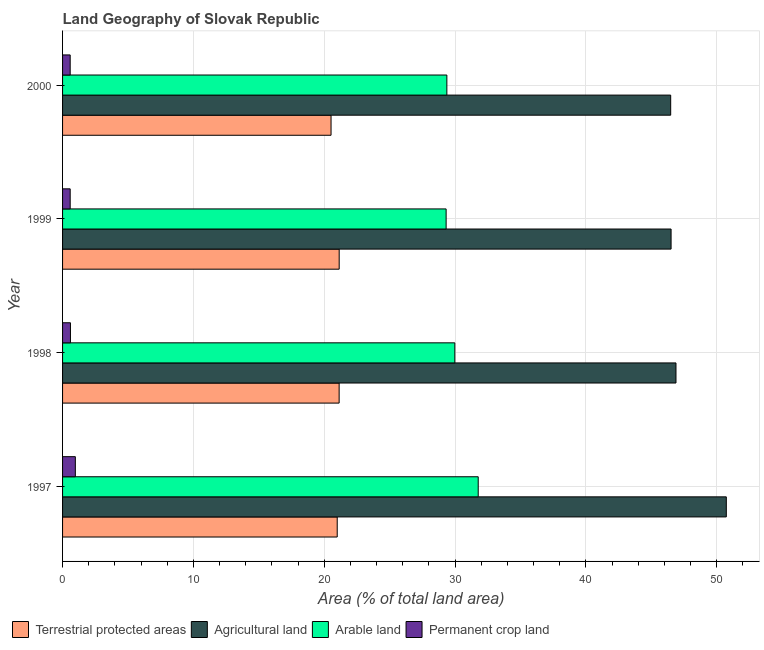How many different coloured bars are there?
Your answer should be very brief. 4. How many groups of bars are there?
Your response must be concise. 4. Are the number of bars per tick equal to the number of legend labels?
Give a very brief answer. Yes. How many bars are there on the 2nd tick from the top?
Keep it short and to the point. 4. How many bars are there on the 3rd tick from the bottom?
Make the answer very short. 4. In how many cases, is the number of bars for a given year not equal to the number of legend labels?
Keep it short and to the point. 0. What is the percentage of area under permanent crop land in 1999?
Give a very brief answer. 0.58. Across all years, what is the maximum percentage of area under permanent crop land?
Your answer should be very brief. 0.98. Across all years, what is the minimum percentage of area under permanent crop land?
Your answer should be compact. 0.58. In which year was the percentage of area under agricultural land maximum?
Provide a succinct answer. 1997. In which year was the percentage of area under permanent crop land minimum?
Offer a very short reply. 2000. What is the total percentage of area under arable land in the graph?
Make the answer very short. 120.43. What is the difference between the percentage of area under permanent crop land in 1998 and that in 2000?
Your answer should be very brief. 0.02. What is the difference between the percentage of area under arable land in 1997 and the percentage of area under agricultural land in 1998?
Make the answer very short. -15.11. What is the average percentage of area under permanent crop land per year?
Your answer should be compact. 0.69. In the year 1999, what is the difference between the percentage of area under permanent crop land and percentage of area under arable land?
Give a very brief answer. -28.73. Is the difference between the percentage of land under terrestrial protection in 1998 and 1999 greater than the difference between the percentage of area under permanent crop land in 1998 and 1999?
Make the answer very short. No. What is the difference between the highest and the second highest percentage of area under agricultural land?
Your answer should be compact. 3.85. In how many years, is the percentage of area under permanent crop land greater than the average percentage of area under permanent crop land taken over all years?
Your answer should be very brief. 1. Is it the case that in every year, the sum of the percentage of area under agricultural land and percentage of land under terrestrial protection is greater than the sum of percentage of area under arable land and percentage of area under permanent crop land?
Offer a very short reply. Yes. What does the 3rd bar from the top in 1999 represents?
Ensure brevity in your answer.  Agricultural land. What does the 3rd bar from the bottom in 1998 represents?
Your answer should be very brief. Arable land. Is it the case that in every year, the sum of the percentage of land under terrestrial protection and percentage of area under agricultural land is greater than the percentage of area under arable land?
Provide a succinct answer. Yes. How many bars are there?
Provide a succinct answer. 16. Are all the bars in the graph horizontal?
Offer a very short reply. Yes. How many legend labels are there?
Your answer should be very brief. 4. How are the legend labels stacked?
Offer a very short reply. Horizontal. What is the title of the graph?
Provide a short and direct response. Land Geography of Slovak Republic. Does "Australia" appear as one of the legend labels in the graph?
Provide a succinct answer. No. What is the label or title of the X-axis?
Ensure brevity in your answer.  Area (% of total land area). What is the Area (% of total land area) of Terrestrial protected areas in 1997?
Your answer should be very brief. 20.99. What is the Area (% of total land area) in Agricultural land in 1997?
Keep it short and to the point. 50.73. What is the Area (% of total land area) in Arable land in 1997?
Your answer should be very brief. 31.77. What is the Area (% of total land area) of Permanent crop land in 1997?
Provide a succinct answer. 0.98. What is the Area (% of total land area) in Terrestrial protected areas in 1998?
Provide a succinct answer. 21.14. What is the Area (% of total land area) of Agricultural land in 1998?
Offer a terse response. 46.88. What is the Area (% of total land area) of Arable land in 1998?
Make the answer very short. 29.98. What is the Area (% of total land area) of Permanent crop land in 1998?
Provide a succinct answer. 0.6. What is the Area (% of total land area) in Terrestrial protected areas in 1999?
Keep it short and to the point. 21.14. What is the Area (% of total land area) in Agricultural land in 1999?
Provide a succinct answer. 46.51. What is the Area (% of total land area) in Arable land in 1999?
Provide a short and direct response. 29.31. What is the Area (% of total land area) in Permanent crop land in 1999?
Give a very brief answer. 0.58. What is the Area (% of total land area) of Terrestrial protected areas in 2000?
Your response must be concise. 20.52. What is the Area (% of total land area) of Agricultural land in 2000?
Provide a succinct answer. 46.48. What is the Area (% of total land area) of Arable land in 2000?
Keep it short and to the point. 29.37. What is the Area (% of total land area) of Permanent crop land in 2000?
Offer a terse response. 0.58. Across all years, what is the maximum Area (% of total land area) in Terrestrial protected areas?
Give a very brief answer. 21.14. Across all years, what is the maximum Area (% of total land area) of Agricultural land?
Your answer should be compact. 50.73. Across all years, what is the maximum Area (% of total land area) in Arable land?
Your answer should be compact. 31.77. Across all years, what is the maximum Area (% of total land area) of Permanent crop land?
Provide a short and direct response. 0.98. Across all years, what is the minimum Area (% of total land area) of Terrestrial protected areas?
Offer a very short reply. 20.52. Across all years, what is the minimum Area (% of total land area) in Agricultural land?
Your answer should be compact. 46.48. Across all years, what is the minimum Area (% of total land area) of Arable land?
Provide a succinct answer. 29.31. Across all years, what is the minimum Area (% of total land area) of Permanent crop land?
Offer a very short reply. 0.58. What is the total Area (% of total land area) of Terrestrial protected areas in the graph?
Make the answer very short. 83.79. What is the total Area (% of total land area) in Agricultural land in the graph?
Your response must be concise. 190.59. What is the total Area (% of total land area) in Arable land in the graph?
Your response must be concise. 120.43. What is the total Area (% of total land area) in Permanent crop land in the graph?
Offer a terse response. 2.74. What is the difference between the Area (% of total land area) of Terrestrial protected areas in 1997 and that in 1998?
Make the answer very short. -0.15. What is the difference between the Area (% of total land area) in Agricultural land in 1997 and that in 1998?
Offer a terse response. 3.85. What is the difference between the Area (% of total land area) of Arable land in 1997 and that in 1998?
Keep it short and to the point. 1.79. What is the difference between the Area (% of total land area) in Permanent crop land in 1997 and that in 1998?
Give a very brief answer. 0.37. What is the difference between the Area (% of total land area) in Terrestrial protected areas in 1997 and that in 1999?
Provide a short and direct response. -0.15. What is the difference between the Area (% of total land area) in Agricultural land in 1997 and that in 1999?
Your answer should be compact. 4.22. What is the difference between the Area (% of total land area) in Arable land in 1997 and that in 1999?
Your answer should be very brief. 2.45. What is the difference between the Area (% of total land area) of Permanent crop land in 1997 and that in 1999?
Your answer should be very brief. 0.4. What is the difference between the Area (% of total land area) in Terrestrial protected areas in 1997 and that in 2000?
Provide a short and direct response. 0.47. What is the difference between the Area (% of total land area) of Agricultural land in 1997 and that in 2000?
Your answer should be compact. 4.25. What is the difference between the Area (% of total land area) in Arable land in 1997 and that in 2000?
Offer a terse response. 2.4. What is the difference between the Area (% of total land area) of Permanent crop land in 1997 and that in 2000?
Your response must be concise. 0.4. What is the difference between the Area (% of total land area) of Terrestrial protected areas in 1998 and that in 1999?
Provide a succinct answer. -0. What is the difference between the Area (% of total land area) in Agricultural land in 1998 and that in 1999?
Keep it short and to the point. 0.37. What is the difference between the Area (% of total land area) in Arable land in 1998 and that in 1999?
Your answer should be very brief. 0.67. What is the difference between the Area (% of total land area) of Permanent crop land in 1998 and that in 1999?
Your response must be concise. 0.02. What is the difference between the Area (% of total land area) of Terrestrial protected areas in 1998 and that in 2000?
Keep it short and to the point. 0.62. What is the difference between the Area (% of total land area) in Agricultural land in 1998 and that in 2000?
Give a very brief answer. 0.4. What is the difference between the Area (% of total land area) in Arable land in 1998 and that in 2000?
Provide a short and direct response. 0.61. What is the difference between the Area (% of total land area) of Permanent crop land in 1998 and that in 2000?
Provide a succinct answer. 0.02. What is the difference between the Area (% of total land area) in Terrestrial protected areas in 1999 and that in 2000?
Make the answer very short. 0.62. What is the difference between the Area (% of total land area) of Agricultural land in 1999 and that in 2000?
Make the answer very short. 0.03. What is the difference between the Area (% of total land area) of Arable land in 1999 and that in 2000?
Your response must be concise. -0.06. What is the difference between the Area (% of total land area) in Terrestrial protected areas in 1997 and the Area (% of total land area) in Agricultural land in 1998?
Give a very brief answer. -25.89. What is the difference between the Area (% of total land area) in Terrestrial protected areas in 1997 and the Area (% of total land area) in Arable land in 1998?
Give a very brief answer. -8.99. What is the difference between the Area (% of total land area) in Terrestrial protected areas in 1997 and the Area (% of total land area) in Permanent crop land in 1998?
Your answer should be very brief. 20.39. What is the difference between the Area (% of total land area) of Agricultural land in 1997 and the Area (% of total land area) of Arable land in 1998?
Offer a terse response. 20.75. What is the difference between the Area (% of total land area) of Agricultural land in 1997 and the Area (% of total land area) of Permanent crop land in 1998?
Offer a very short reply. 50.12. What is the difference between the Area (% of total land area) in Arable land in 1997 and the Area (% of total land area) in Permanent crop land in 1998?
Your response must be concise. 31.16. What is the difference between the Area (% of total land area) in Terrestrial protected areas in 1997 and the Area (% of total land area) in Agricultural land in 1999?
Your response must be concise. -25.52. What is the difference between the Area (% of total land area) in Terrestrial protected areas in 1997 and the Area (% of total land area) in Arable land in 1999?
Provide a succinct answer. -8.32. What is the difference between the Area (% of total land area) of Terrestrial protected areas in 1997 and the Area (% of total land area) of Permanent crop land in 1999?
Offer a very short reply. 20.41. What is the difference between the Area (% of total land area) in Agricultural land in 1997 and the Area (% of total land area) in Arable land in 1999?
Keep it short and to the point. 21.41. What is the difference between the Area (% of total land area) of Agricultural land in 1997 and the Area (% of total land area) of Permanent crop land in 1999?
Offer a terse response. 50.15. What is the difference between the Area (% of total land area) of Arable land in 1997 and the Area (% of total land area) of Permanent crop land in 1999?
Make the answer very short. 31.18. What is the difference between the Area (% of total land area) of Terrestrial protected areas in 1997 and the Area (% of total land area) of Agricultural land in 2000?
Your response must be concise. -25.49. What is the difference between the Area (% of total land area) in Terrestrial protected areas in 1997 and the Area (% of total land area) in Arable land in 2000?
Give a very brief answer. -8.38. What is the difference between the Area (% of total land area) of Terrestrial protected areas in 1997 and the Area (% of total land area) of Permanent crop land in 2000?
Keep it short and to the point. 20.41. What is the difference between the Area (% of total land area) of Agricultural land in 1997 and the Area (% of total land area) of Arable land in 2000?
Your response must be concise. 21.36. What is the difference between the Area (% of total land area) of Agricultural land in 1997 and the Area (% of total land area) of Permanent crop land in 2000?
Ensure brevity in your answer.  50.15. What is the difference between the Area (% of total land area) in Arable land in 1997 and the Area (% of total land area) in Permanent crop land in 2000?
Offer a terse response. 31.19. What is the difference between the Area (% of total land area) of Terrestrial protected areas in 1998 and the Area (% of total land area) of Agricultural land in 1999?
Give a very brief answer. -25.37. What is the difference between the Area (% of total land area) of Terrestrial protected areas in 1998 and the Area (% of total land area) of Arable land in 1999?
Ensure brevity in your answer.  -8.18. What is the difference between the Area (% of total land area) in Terrestrial protected areas in 1998 and the Area (% of total land area) in Permanent crop land in 1999?
Your answer should be compact. 20.56. What is the difference between the Area (% of total land area) of Agricultural land in 1998 and the Area (% of total land area) of Arable land in 1999?
Give a very brief answer. 17.57. What is the difference between the Area (% of total land area) in Agricultural land in 1998 and the Area (% of total land area) in Permanent crop land in 1999?
Make the answer very short. 46.3. What is the difference between the Area (% of total land area) in Arable land in 1998 and the Area (% of total land area) in Permanent crop land in 1999?
Offer a very short reply. 29.4. What is the difference between the Area (% of total land area) of Terrestrial protected areas in 1998 and the Area (% of total land area) of Agricultural land in 2000?
Your answer should be compact. -25.34. What is the difference between the Area (% of total land area) of Terrestrial protected areas in 1998 and the Area (% of total land area) of Arable land in 2000?
Your answer should be very brief. -8.23. What is the difference between the Area (% of total land area) of Terrestrial protected areas in 1998 and the Area (% of total land area) of Permanent crop land in 2000?
Give a very brief answer. 20.56. What is the difference between the Area (% of total land area) in Agricultural land in 1998 and the Area (% of total land area) in Arable land in 2000?
Provide a short and direct response. 17.51. What is the difference between the Area (% of total land area) in Agricultural land in 1998 and the Area (% of total land area) in Permanent crop land in 2000?
Ensure brevity in your answer.  46.3. What is the difference between the Area (% of total land area) in Arable land in 1998 and the Area (% of total land area) in Permanent crop land in 2000?
Make the answer very short. 29.4. What is the difference between the Area (% of total land area) of Terrestrial protected areas in 1999 and the Area (% of total land area) of Agricultural land in 2000?
Provide a short and direct response. -25.34. What is the difference between the Area (% of total land area) in Terrestrial protected areas in 1999 and the Area (% of total land area) in Arable land in 2000?
Your answer should be compact. -8.23. What is the difference between the Area (% of total land area) in Terrestrial protected areas in 1999 and the Area (% of total land area) in Permanent crop land in 2000?
Provide a short and direct response. 20.56. What is the difference between the Area (% of total land area) in Agricultural land in 1999 and the Area (% of total land area) in Arable land in 2000?
Make the answer very short. 17.14. What is the difference between the Area (% of total land area) of Agricultural land in 1999 and the Area (% of total land area) of Permanent crop land in 2000?
Your response must be concise. 45.93. What is the difference between the Area (% of total land area) of Arable land in 1999 and the Area (% of total land area) of Permanent crop land in 2000?
Ensure brevity in your answer.  28.73. What is the average Area (% of total land area) in Terrestrial protected areas per year?
Give a very brief answer. 20.95. What is the average Area (% of total land area) in Agricultural land per year?
Give a very brief answer. 47.65. What is the average Area (% of total land area) of Arable land per year?
Your answer should be compact. 30.11. What is the average Area (% of total land area) in Permanent crop land per year?
Your answer should be very brief. 0.69. In the year 1997, what is the difference between the Area (% of total land area) in Terrestrial protected areas and Area (% of total land area) in Agricultural land?
Ensure brevity in your answer.  -29.74. In the year 1997, what is the difference between the Area (% of total land area) in Terrestrial protected areas and Area (% of total land area) in Arable land?
Provide a succinct answer. -10.78. In the year 1997, what is the difference between the Area (% of total land area) of Terrestrial protected areas and Area (% of total land area) of Permanent crop land?
Offer a terse response. 20.01. In the year 1997, what is the difference between the Area (% of total land area) of Agricultural land and Area (% of total land area) of Arable land?
Ensure brevity in your answer.  18.96. In the year 1997, what is the difference between the Area (% of total land area) in Agricultural land and Area (% of total land area) in Permanent crop land?
Offer a terse response. 49.75. In the year 1997, what is the difference between the Area (% of total land area) in Arable land and Area (% of total land area) in Permanent crop land?
Ensure brevity in your answer.  30.79. In the year 1998, what is the difference between the Area (% of total land area) of Terrestrial protected areas and Area (% of total land area) of Agricultural land?
Give a very brief answer. -25.74. In the year 1998, what is the difference between the Area (% of total land area) of Terrestrial protected areas and Area (% of total land area) of Arable land?
Give a very brief answer. -8.84. In the year 1998, what is the difference between the Area (% of total land area) of Terrestrial protected areas and Area (% of total land area) of Permanent crop land?
Your answer should be compact. 20.53. In the year 1998, what is the difference between the Area (% of total land area) in Agricultural land and Area (% of total land area) in Arable land?
Provide a short and direct response. 16.9. In the year 1998, what is the difference between the Area (% of total land area) of Agricultural land and Area (% of total land area) of Permanent crop land?
Your answer should be very brief. 46.28. In the year 1998, what is the difference between the Area (% of total land area) of Arable land and Area (% of total land area) of Permanent crop land?
Give a very brief answer. 29.38. In the year 1999, what is the difference between the Area (% of total land area) in Terrestrial protected areas and Area (% of total land area) in Agricultural land?
Make the answer very short. -25.37. In the year 1999, what is the difference between the Area (% of total land area) of Terrestrial protected areas and Area (% of total land area) of Arable land?
Ensure brevity in your answer.  -8.17. In the year 1999, what is the difference between the Area (% of total land area) in Terrestrial protected areas and Area (% of total land area) in Permanent crop land?
Keep it short and to the point. 20.56. In the year 1999, what is the difference between the Area (% of total land area) of Agricultural land and Area (% of total land area) of Arable land?
Give a very brief answer. 17.19. In the year 1999, what is the difference between the Area (% of total land area) in Agricultural land and Area (% of total land area) in Permanent crop land?
Your answer should be compact. 45.93. In the year 1999, what is the difference between the Area (% of total land area) in Arable land and Area (% of total land area) in Permanent crop land?
Provide a succinct answer. 28.73. In the year 2000, what is the difference between the Area (% of total land area) in Terrestrial protected areas and Area (% of total land area) in Agricultural land?
Your answer should be compact. -25.96. In the year 2000, what is the difference between the Area (% of total land area) of Terrestrial protected areas and Area (% of total land area) of Arable land?
Ensure brevity in your answer.  -8.85. In the year 2000, what is the difference between the Area (% of total land area) in Terrestrial protected areas and Area (% of total land area) in Permanent crop land?
Your answer should be compact. 19.94. In the year 2000, what is the difference between the Area (% of total land area) of Agricultural land and Area (% of total land area) of Arable land?
Provide a succinct answer. 17.11. In the year 2000, what is the difference between the Area (% of total land area) of Agricultural land and Area (% of total land area) of Permanent crop land?
Keep it short and to the point. 45.89. In the year 2000, what is the difference between the Area (% of total land area) in Arable land and Area (% of total land area) in Permanent crop land?
Keep it short and to the point. 28.79. What is the ratio of the Area (% of total land area) in Terrestrial protected areas in 1997 to that in 1998?
Your answer should be very brief. 0.99. What is the ratio of the Area (% of total land area) of Agricultural land in 1997 to that in 1998?
Your answer should be compact. 1.08. What is the ratio of the Area (% of total land area) in Arable land in 1997 to that in 1998?
Keep it short and to the point. 1.06. What is the ratio of the Area (% of total land area) in Permanent crop land in 1997 to that in 1998?
Make the answer very short. 1.62. What is the ratio of the Area (% of total land area) of Terrestrial protected areas in 1997 to that in 1999?
Ensure brevity in your answer.  0.99. What is the ratio of the Area (% of total land area) in Agricultural land in 1997 to that in 1999?
Give a very brief answer. 1.09. What is the ratio of the Area (% of total land area) of Arable land in 1997 to that in 1999?
Offer a very short reply. 1.08. What is the ratio of the Area (% of total land area) in Permanent crop land in 1997 to that in 1999?
Make the answer very short. 1.68. What is the ratio of the Area (% of total land area) of Agricultural land in 1997 to that in 2000?
Offer a very short reply. 1.09. What is the ratio of the Area (% of total land area) of Arable land in 1997 to that in 2000?
Give a very brief answer. 1.08. What is the ratio of the Area (% of total land area) in Permanent crop land in 1997 to that in 2000?
Provide a short and direct response. 1.68. What is the ratio of the Area (% of total land area) in Arable land in 1998 to that in 1999?
Keep it short and to the point. 1.02. What is the ratio of the Area (% of total land area) in Permanent crop land in 1998 to that in 1999?
Provide a succinct answer. 1.04. What is the ratio of the Area (% of total land area) of Terrestrial protected areas in 1998 to that in 2000?
Ensure brevity in your answer.  1.03. What is the ratio of the Area (% of total land area) in Agricultural land in 1998 to that in 2000?
Offer a terse response. 1.01. What is the ratio of the Area (% of total land area) of Arable land in 1998 to that in 2000?
Your answer should be compact. 1.02. What is the ratio of the Area (% of total land area) of Permanent crop land in 1998 to that in 2000?
Keep it short and to the point. 1.04. What is the ratio of the Area (% of total land area) in Terrestrial protected areas in 1999 to that in 2000?
Provide a succinct answer. 1.03. What is the ratio of the Area (% of total land area) in Agricultural land in 1999 to that in 2000?
Provide a short and direct response. 1. What is the ratio of the Area (% of total land area) of Permanent crop land in 1999 to that in 2000?
Offer a terse response. 1. What is the difference between the highest and the second highest Area (% of total land area) of Terrestrial protected areas?
Provide a succinct answer. 0. What is the difference between the highest and the second highest Area (% of total land area) in Agricultural land?
Make the answer very short. 3.85. What is the difference between the highest and the second highest Area (% of total land area) in Arable land?
Offer a terse response. 1.79. What is the difference between the highest and the second highest Area (% of total land area) of Permanent crop land?
Ensure brevity in your answer.  0.37. What is the difference between the highest and the lowest Area (% of total land area) in Terrestrial protected areas?
Provide a short and direct response. 0.62. What is the difference between the highest and the lowest Area (% of total land area) of Agricultural land?
Provide a short and direct response. 4.25. What is the difference between the highest and the lowest Area (% of total land area) in Arable land?
Your answer should be compact. 2.45. What is the difference between the highest and the lowest Area (% of total land area) of Permanent crop land?
Offer a very short reply. 0.4. 